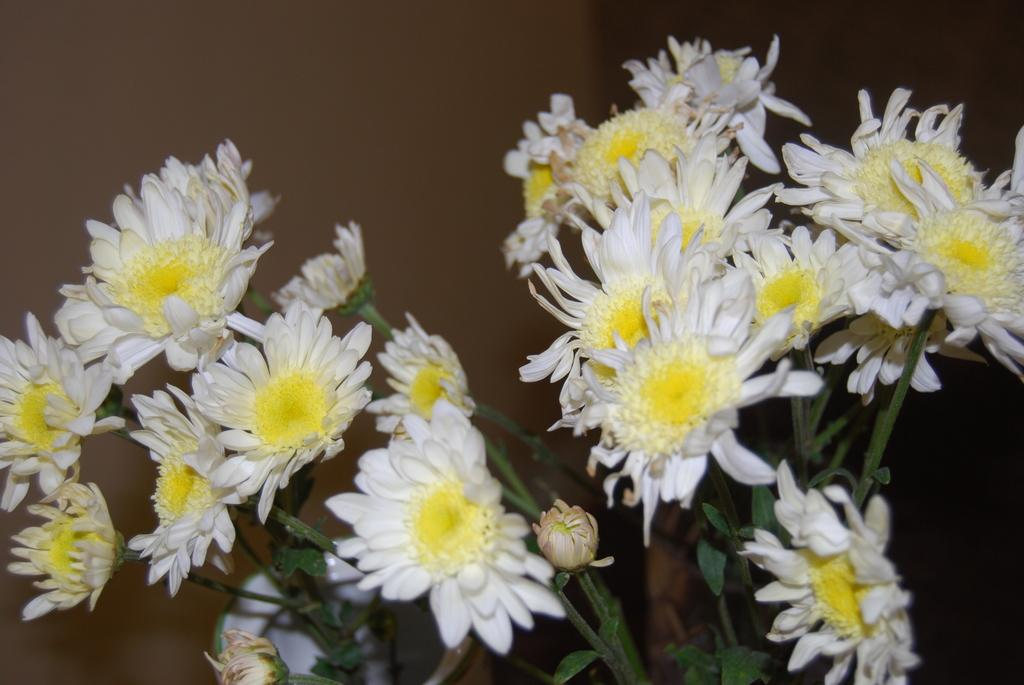What type of plants can be seen in the image? There are flowers in the image. What is visible in the background of the image? There is a wall in the background of the image. Reasoning: Let' Let's think step by step in order to produce the conversation. We start by identifying the main subject in the image, which is the flowers. Then, we expand the conversation to include the background of the image, which features a wall. Each question is designed to elicit a specific detail about the image that is known from the provided facts. Absurd Question/Answer: Where is the pan placed on the stove in the image? There is no pan or stove present in the image; it only features flowers and a wall in the background. How many holes are visible in the pan on the stove in the image? There is no pan or stove present in the image; it only features flowers and a wall in the background. 